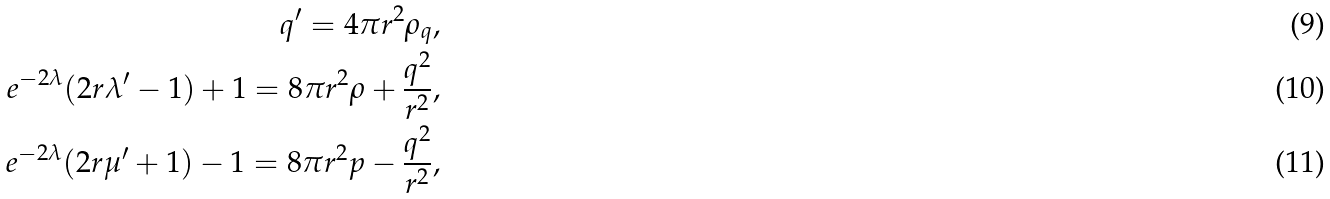<formula> <loc_0><loc_0><loc_500><loc_500>q ^ { \prime } = 4 \pi r ^ { 2 } \rho _ { q } , \\ e ^ { - 2 \lambda } ( 2 r \lambda ^ { \prime } - 1 ) + 1 = 8 \pi r ^ { 2 } \rho + \frac { q ^ { 2 } } { r ^ { 2 } } , \\ e ^ { - 2 \lambda } ( 2 r \mu ^ { \prime } + 1 ) - 1 = 8 \pi r ^ { 2 } p - \frac { q ^ { 2 } } { r ^ { 2 } } ,</formula> 